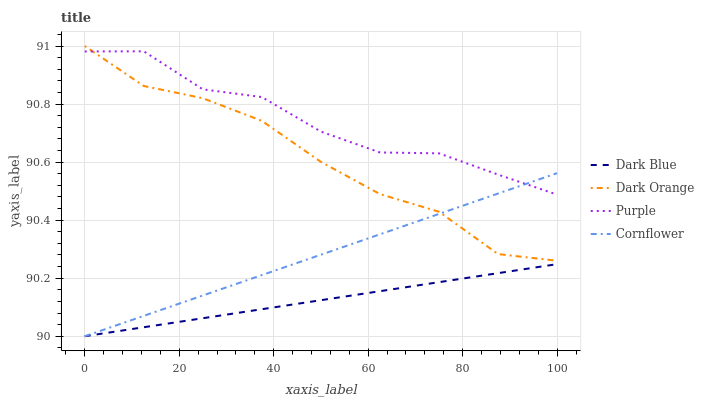Does Dark Blue have the minimum area under the curve?
Answer yes or no. Yes. Does Purple have the maximum area under the curve?
Answer yes or no. Yes. Does Cornflower have the minimum area under the curve?
Answer yes or no. No. Does Cornflower have the maximum area under the curve?
Answer yes or no. No. Is Dark Blue the smoothest?
Answer yes or no. Yes. Is Purple the roughest?
Answer yes or no. Yes. Is Cornflower the smoothest?
Answer yes or no. No. Is Cornflower the roughest?
Answer yes or no. No. Does Dark Blue have the lowest value?
Answer yes or no. Yes. Does Dark Orange have the lowest value?
Answer yes or no. No. Does Dark Orange have the highest value?
Answer yes or no. Yes. Does Cornflower have the highest value?
Answer yes or no. No. Is Dark Blue less than Dark Orange?
Answer yes or no. Yes. Is Purple greater than Dark Blue?
Answer yes or no. Yes. Does Dark Orange intersect Cornflower?
Answer yes or no. Yes. Is Dark Orange less than Cornflower?
Answer yes or no. No. Is Dark Orange greater than Cornflower?
Answer yes or no. No. Does Dark Blue intersect Dark Orange?
Answer yes or no. No. 